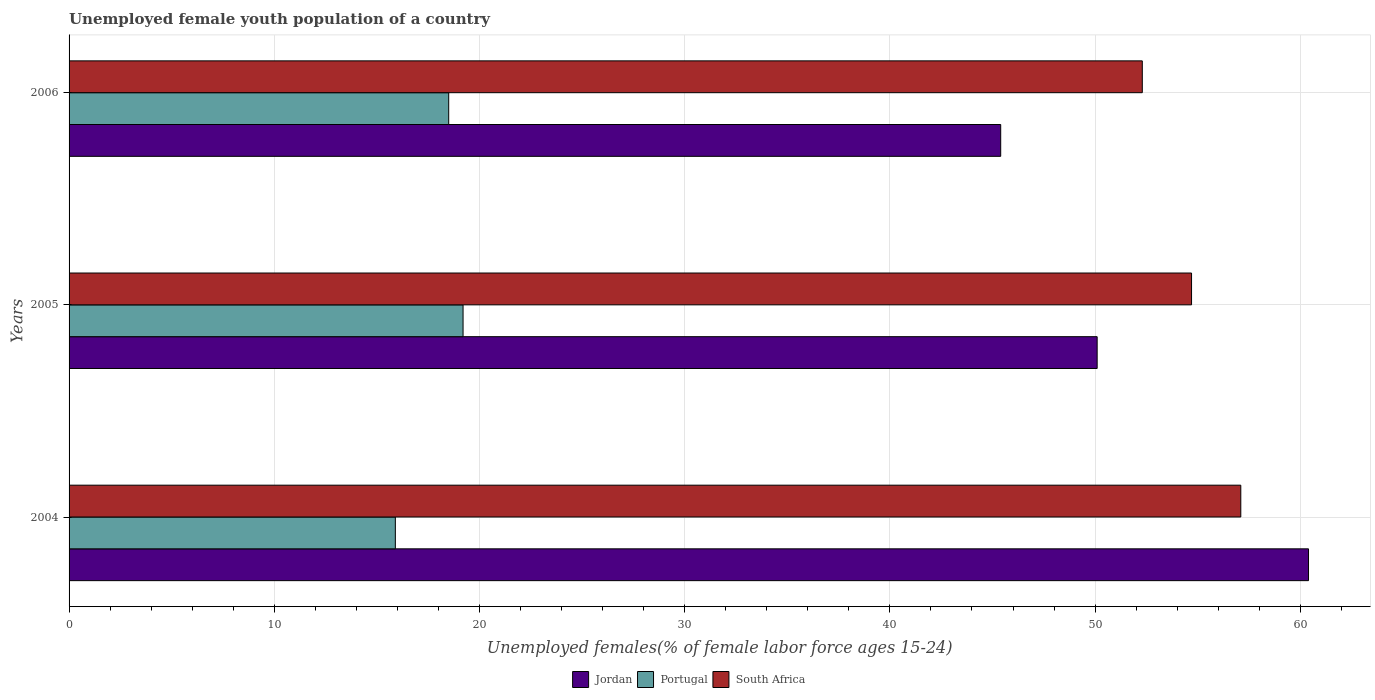How many groups of bars are there?
Make the answer very short. 3. Are the number of bars per tick equal to the number of legend labels?
Ensure brevity in your answer.  Yes. Are the number of bars on each tick of the Y-axis equal?
Give a very brief answer. Yes. How many bars are there on the 3rd tick from the bottom?
Provide a succinct answer. 3. What is the label of the 2nd group of bars from the top?
Offer a very short reply. 2005. In how many cases, is the number of bars for a given year not equal to the number of legend labels?
Ensure brevity in your answer.  0. What is the percentage of unemployed female youth population in Portugal in 2004?
Make the answer very short. 15.9. Across all years, what is the maximum percentage of unemployed female youth population in South Africa?
Give a very brief answer. 57.1. Across all years, what is the minimum percentage of unemployed female youth population in Portugal?
Ensure brevity in your answer.  15.9. In which year was the percentage of unemployed female youth population in Jordan maximum?
Your answer should be very brief. 2004. What is the total percentage of unemployed female youth population in Jordan in the graph?
Make the answer very short. 155.9. What is the difference between the percentage of unemployed female youth population in Jordan in 2004 and that in 2005?
Give a very brief answer. 10.3. What is the difference between the percentage of unemployed female youth population in Jordan in 2006 and the percentage of unemployed female youth population in Portugal in 2005?
Make the answer very short. 26.2. What is the average percentage of unemployed female youth population in Portugal per year?
Your answer should be very brief. 17.87. In the year 2006, what is the difference between the percentage of unemployed female youth population in Jordan and percentage of unemployed female youth population in Portugal?
Your response must be concise. 26.9. In how many years, is the percentage of unemployed female youth population in Portugal greater than 56 %?
Ensure brevity in your answer.  0. What is the ratio of the percentage of unemployed female youth population in South Africa in 2005 to that in 2006?
Provide a short and direct response. 1.05. Is the percentage of unemployed female youth population in South Africa in 2004 less than that in 2006?
Offer a very short reply. No. Is the difference between the percentage of unemployed female youth population in Jordan in 2004 and 2005 greater than the difference between the percentage of unemployed female youth population in Portugal in 2004 and 2005?
Keep it short and to the point. Yes. What is the difference between the highest and the second highest percentage of unemployed female youth population in South Africa?
Keep it short and to the point. 2.4. What is the difference between the highest and the lowest percentage of unemployed female youth population in Portugal?
Provide a short and direct response. 3.3. What does the 1st bar from the top in 2004 represents?
Provide a succinct answer. South Africa. Is it the case that in every year, the sum of the percentage of unemployed female youth population in Jordan and percentage of unemployed female youth population in South Africa is greater than the percentage of unemployed female youth population in Portugal?
Provide a succinct answer. Yes. Are all the bars in the graph horizontal?
Give a very brief answer. Yes. What is the difference between two consecutive major ticks on the X-axis?
Provide a succinct answer. 10. Does the graph contain grids?
Your response must be concise. Yes. Where does the legend appear in the graph?
Ensure brevity in your answer.  Bottom center. How many legend labels are there?
Make the answer very short. 3. What is the title of the graph?
Offer a very short reply. Unemployed female youth population of a country. Does "Azerbaijan" appear as one of the legend labels in the graph?
Keep it short and to the point. No. What is the label or title of the X-axis?
Make the answer very short. Unemployed females(% of female labor force ages 15-24). What is the label or title of the Y-axis?
Ensure brevity in your answer.  Years. What is the Unemployed females(% of female labor force ages 15-24) in Jordan in 2004?
Your response must be concise. 60.4. What is the Unemployed females(% of female labor force ages 15-24) in Portugal in 2004?
Ensure brevity in your answer.  15.9. What is the Unemployed females(% of female labor force ages 15-24) of South Africa in 2004?
Provide a succinct answer. 57.1. What is the Unemployed females(% of female labor force ages 15-24) of Jordan in 2005?
Provide a succinct answer. 50.1. What is the Unemployed females(% of female labor force ages 15-24) of Portugal in 2005?
Your answer should be very brief. 19.2. What is the Unemployed females(% of female labor force ages 15-24) of South Africa in 2005?
Keep it short and to the point. 54.7. What is the Unemployed females(% of female labor force ages 15-24) of Jordan in 2006?
Provide a succinct answer. 45.4. What is the Unemployed females(% of female labor force ages 15-24) in South Africa in 2006?
Offer a very short reply. 52.3. Across all years, what is the maximum Unemployed females(% of female labor force ages 15-24) of Jordan?
Your response must be concise. 60.4. Across all years, what is the maximum Unemployed females(% of female labor force ages 15-24) in Portugal?
Provide a succinct answer. 19.2. Across all years, what is the maximum Unemployed females(% of female labor force ages 15-24) of South Africa?
Offer a very short reply. 57.1. Across all years, what is the minimum Unemployed females(% of female labor force ages 15-24) in Jordan?
Provide a succinct answer. 45.4. Across all years, what is the minimum Unemployed females(% of female labor force ages 15-24) of Portugal?
Offer a very short reply. 15.9. Across all years, what is the minimum Unemployed females(% of female labor force ages 15-24) in South Africa?
Give a very brief answer. 52.3. What is the total Unemployed females(% of female labor force ages 15-24) of Jordan in the graph?
Provide a succinct answer. 155.9. What is the total Unemployed females(% of female labor force ages 15-24) of Portugal in the graph?
Your answer should be very brief. 53.6. What is the total Unemployed females(% of female labor force ages 15-24) of South Africa in the graph?
Offer a very short reply. 164.1. What is the difference between the Unemployed females(% of female labor force ages 15-24) in Portugal in 2004 and that in 2005?
Ensure brevity in your answer.  -3.3. What is the difference between the Unemployed females(% of female labor force ages 15-24) in Portugal in 2004 and that in 2006?
Give a very brief answer. -2.6. What is the difference between the Unemployed females(% of female labor force ages 15-24) of South Africa in 2005 and that in 2006?
Give a very brief answer. 2.4. What is the difference between the Unemployed females(% of female labor force ages 15-24) in Jordan in 2004 and the Unemployed females(% of female labor force ages 15-24) in Portugal in 2005?
Your response must be concise. 41.2. What is the difference between the Unemployed females(% of female labor force ages 15-24) in Jordan in 2004 and the Unemployed females(% of female labor force ages 15-24) in South Africa in 2005?
Keep it short and to the point. 5.7. What is the difference between the Unemployed females(% of female labor force ages 15-24) of Portugal in 2004 and the Unemployed females(% of female labor force ages 15-24) of South Africa in 2005?
Keep it short and to the point. -38.8. What is the difference between the Unemployed females(% of female labor force ages 15-24) of Jordan in 2004 and the Unemployed females(% of female labor force ages 15-24) of Portugal in 2006?
Offer a terse response. 41.9. What is the difference between the Unemployed females(% of female labor force ages 15-24) of Jordan in 2004 and the Unemployed females(% of female labor force ages 15-24) of South Africa in 2006?
Offer a very short reply. 8.1. What is the difference between the Unemployed females(% of female labor force ages 15-24) of Portugal in 2004 and the Unemployed females(% of female labor force ages 15-24) of South Africa in 2006?
Your response must be concise. -36.4. What is the difference between the Unemployed females(% of female labor force ages 15-24) in Jordan in 2005 and the Unemployed females(% of female labor force ages 15-24) in Portugal in 2006?
Your answer should be compact. 31.6. What is the difference between the Unemployed females(% of female labor force ages 15-24) in Portugal in 2005 and the Unemployed females(% of female labor force ages 15-24) in South Africa in 2006?
Offer a very short reply. -33.1. What is the average Unemployed females(% of female labor force ages 15-24) of Jordan per year?
Give a very brief answer. 51.97. What is the average Unemployed females(% of female labor force ages 15-24) of Portugal per year?
Offer a terse response. 17.87. What is the average Unemployed females(% of female labor force ages 15-24) of South Africa per year?
Provide a succinct answer. 54.7. In the year 2004, what is the difference between the Unemployed females(% of female labor force ages 15-24) of Jordan and Unemployed females(% of female labor force ages 15-24) of Portugal?
Give a very brief answer. 44.5. In the year 2004, what is the difference between the Unemployed females(% of female labor force ages 15-24) of Jordan and Unemployed females(% of female labor force ages 15-24) of South Africa?
Make the answer very short. 3.3. In the year 2004, what is the difference between the Unemployed females(% of female labor force ages 15-24) in Portugal and Unemployed females(% of female labor force ages 15-24) in South Africa?
Give a very brief answer. -41.2. In the year 2005, what is the difference between the Unemployed females(% of female labor force ages 15-24) in Jordan and Unemployed females(% of female labor force ages 15-24) in Portugal?
Offer a terse response. 30.9. In the year 2005, what is the difference between the Unemployed females(% of female labor force ages 15-24) of Portugal and Unemployed females(% of female labor force ages 15-24) of South Africa?
Ensure brevity in your answer.  -35.5. In the year 2006, what is the difference between the Unemployed females(% of female labor force ages 15-24) in Jordan and Unemployed females(% of female labor force ages 15-24) in Portugal?
Ensure brevity in your answer.  26.9. In the year 2006, what is the difference between the Unemployed females(% of female labor force ages 15-24) of Jordan and Unemployed females(% of female labor force ages 15-24) of South Africa?
Provide a short and direct response. -6.9. In the year 2006, what is the difference between the Unemployed females(% of female labor force ages 15-24) of Portugal and Unemployed females(% of female labor force ages 15-24) of South Africa?
Your answer should be compact. -33.8. What is the ratio of the Unemployed females(% of female labor force ages 15-24) of Jordan in 2004 to that in 2005?
Make the answer very short. 1.21. What is the ratio of the Unemployed females(% of female labor force ages 15-24) of Portugal in 2004 to that in 2005?
Keep it short and to the point. 0.83. What is the ratio of the Unemployed females(% of female labor force ages 15-24) in South Africa in 2004 to that in 2005?
Provide a succinct answer. 1.04. What is the ratio of the Unemployed females(% of female labor force ages 15-24) of Jordan in 2004 to that in 2006?
Your answer should be very brief. 1.33. What is the ratio of the Unemployed females(% of female labor force ages 15-24) of Portugal in 2004 to that in 2006?
Your answer should be compact. 0.86. What is the ratio of the Unemployed females(% of female labor force ages 15-24) of South Africa in 2004 to that in 2006?
Make the answer very short. 1.09. What is the ratio of the Unemployed females(% of female labor force ages 15-24) of Jordan in 2005 to that in 2006?
Give a very brief answer. 1.1. What is the ratio of the Unemployed females(% of female labor force ages 15-24) of Portugal in 2005 to that in 2006?
Make the answer very short. 1.04. What is the ratio of the Unemployed females(% of female labor force ages 15-24) in South Africa in 2005 to that in 2006?
Ensure brevity in your answer.  1.05. What is the difference between the highest and the second highest Unemployed females(% of female labor force ages 15-24) of Portugal?
Offer a very short reply. 0.7. What is the difference between the highest and the second highest Unemployed females(% of female labor force ages 15-24) in South Africa?
Offer a terse response. 2.4. What is the difference between the highest and the lowest Unemployed females(% of female labor force ages 15-24) of Jordan?
Offer a very short reply. 15. 